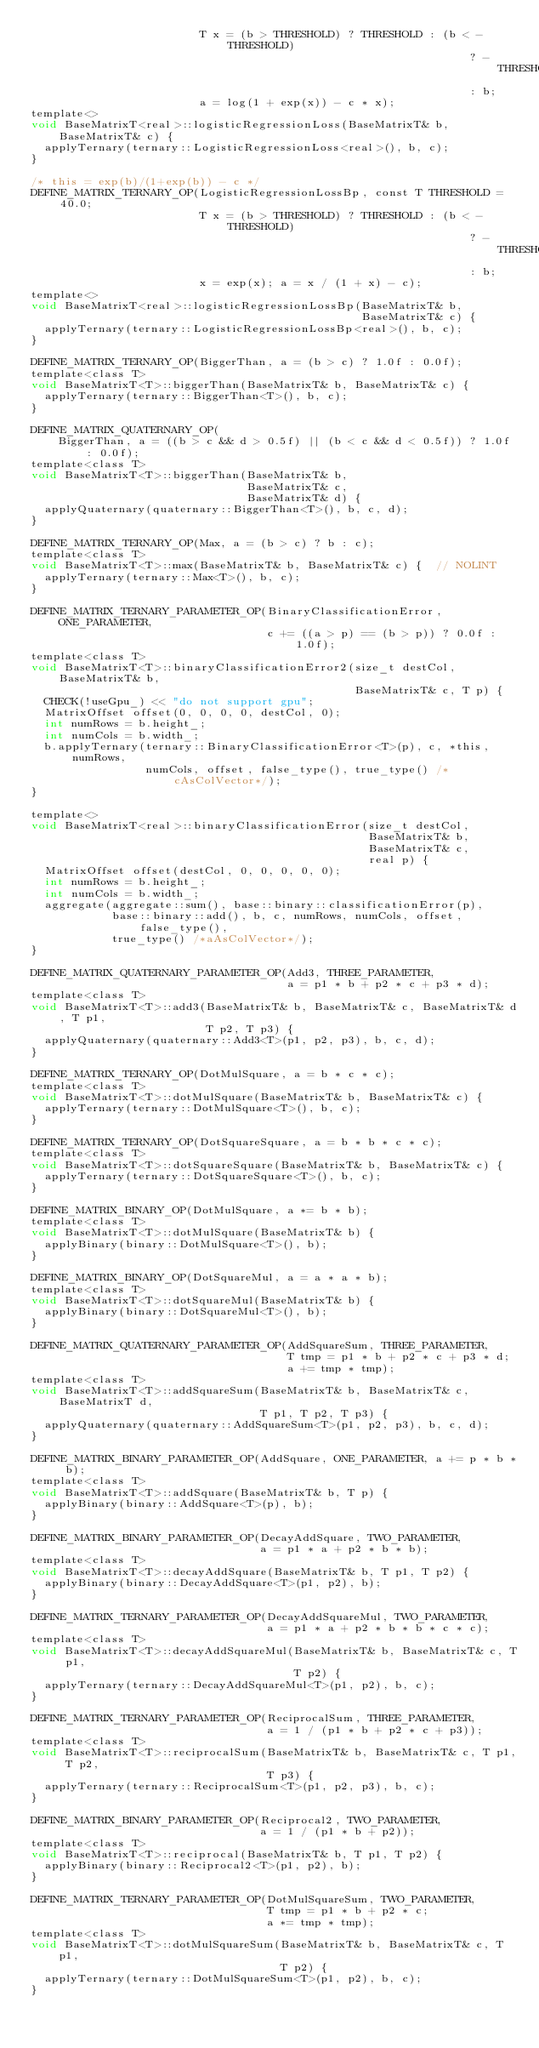<code> <loc_0><loc_0><loc_500><loc_500><_Cuda_>                         T x = (b > THRESHOLD) ? THRESHOLD : (b < -THRESHOLD)
                                                                 ? -THRESHOLD
                                                                 : b;
                         a = log(1 + exp(x)) - c * x);
template<>
void BaseMatrixT<real>::logisticRegressionLoss(BaseMatrixT& b, BaseMatrixT& c) {
  applyTernary(ternary::LogisticRegressionLoss<real>(), b, c);
}

/* this = exp(b)/(1+exp(b)) - c */
DEFINE_MATRIX_TERNARY_OP(LogisticRegressionLossBp, const T THRESHOLD = 40.0;
                         T x = (b > THRESHOLD) ? THRESHOLD : (b < -THRESHOLD)
                                                                 ? -THRESHOLD
                                                                 : b;
                         x = exp(x); a = x / (1 + x) - c);
template<>
void BaseMatrixT<real>::logisticRegressionLossBp(BaseMatrixT& b,
                                                 BaseMatrixT& c) {
  applyTernary(ternary::LogisticRegressionLossBp<real>(), b, c);
}

DEFINE_MATRIX_TERNARY_OP(BiggerThan, a = (b > c) ? 1.0f : 0.0f);
template<class T>
void BaseMatrixT<T>::biggerThan(BaseMatrixT& b, BaseMatrixT& c) {
  applyTernary(ternary::BiggerThan<T>(), b, c);
}

DEFINE_MATRIX_QUATERNARY_OP(
    BiggerThan, a = ((b > c && d > 0.5f) || (b < c && d < 0.5f)) ? 1.0f : 0.0f);
template<class T>
void BaseMatrixT<T>::biggerThan(BaseMatrixT& b,
                                BaseMatrixT& c,
                                BaseMatrixT& d) {
  applyQuaternary(quaternary::BiggerThan<T>(), b, c, d);
}

DEFINE_MATRIX_TERNARY_OP(Max, a = (b > c) ? b : c);
template<class T>
void BaseMatrixT<T>::max(BaseMatrixT& b, BaseMatrixT& c) {  // NOLINT
  applyTernary(ternary::Max<T>(), b, c);
}

DEFINE_MATRIX_TERNARY_PARAMETER_OP(BinaryClassificationError, ONE_PARAMETER,
                                   c += ((a > p) == (b > p)) ? 0.0f : 1.0f);
template<class T>
void BaseMatrixT<T>::binaryClassificationError2(size_t destCol, BaseMatrixT& b,
                                                BaseMatrixT& c, T p) {
  CHECK(!useGpu_) << "do not support gpu";
  MatrixOffset offset(0, 0, 0, 0, destCol, 0);
  int numRows = b.height_;
  int numCols = b.width_;
  b.applyTernary(ternary::BinaryClassificationError<T>(p), c, *this, numRows,
                 numCols, offset, false_type(), true_type() /*cAsColVector*/);
}

template<>
void BaseMatrixT<real>::binaryClassificationError(size_t destCol,
                                                  BaseMatrixT& b,
                                                  BaseMatrixT& c,
                                                  real p) {
  MatrixOffset offset(destCol, 0, 0, 0, 0, 0);
  int numRows = b.height_;
  int numCols = b.width_;
  aggregate(aggregate::sum(), base::binary::classificationError(p),
            base::binary::add(), b, c, numRows, numCols, offset, false_type(),
            true_type() /*aAsColVector*/);
}

DEFINE_MATRIX_QUATERNARY_PARAMETER_OP(Add3, THREE_PARAMETER,
                                      a = p1 * b + p2 * c + p3 * d);
template<class T>
void BaseMatrixT<T>::add3(BaseMatrixT& b, BaseMatrixT& c, BaseMatrixT& d, T p1,
                          T p2, T p3) {
  applyQuaternary(quaternary::Add3<T>(p1, p2, p3), b, c, d);
}

DEFINE_MATRIX_TERNARY_OP(DotMulSquare, a = b * c * c);
template<class T>
void BaseMatrixT<T>::dotMulSquare(BaseMatrixT& b, BaseMatrixT& c) {
  applyTernary(ternary::DotMulSquare<T>(), b, c);
}

DEFINE_MATRIX_TERNARY_OP(DotSquareSquare, a = b * b * c * c);
template<class T>
void BaseMatrixT<T>::dotSquareSquare(BaseMatrixT& b, BaseMatrixT& c) {
  applyTernary(ternary::DotSquareSquare<T>(), b, c);
}

DEFINE_MATRIX_BINARY_OP(DotMulSquare, a *= b * b);
template<class T>
void BaseMatrixT<T>::dotMulSquare(BaseMatrixT& b) {
  applyBinary(binary::DotMulSquare<T>(), b);
}

DEFINE_MATRIX_BINARY_OP(DotSquareMul, a = a * a * b);
template<class T>
void BaseMatrixT<T>::dotSquareMul(BaseMatrixT& b) {
  applyBinary(binary::DotSquareMul<T>(), b);
}

DEFINE_MATRIX_QUATERNARY_PARAMETER_OP(AddSquareSum, THREE_PARAMETER,
                                      T tmp = p1 * b + p2 * c + p3 * d;
                                      a += tmp * tmp);
template<class T>
void BaseMatrixT<T>::addSquareSum(BaseMatrixT& b, BaseMatrixT& c, BaseMatrixT d,
                                  T p1, T p2, T p3) {
  applyQuaternary(quaternary::AddSquareSum<T>(p1, p2, p3), b, c, d);
}

DEFINE_MATRIX_BINARY_PARAMETER_OP(AddSquare, ONE_PARAMETER, a += p * b * b);
template<class T>
void BaseMatrixT<T>::addSquare(BaseMatrixT& b, T p) {
  applyBinary(binary::AddSquare<T>(p), b);
}

DEFINE_MATRIX_BINARY_PARAMETER_OP(DecayAddSquare, TWO_PARAMETER,
                                  a = p1 * a + p2 * b * b);
template<class T>
void BaseMatrixT<T>::decayAddSquare(BaseMatrixT& b, T p1, T p2) {
  applyBinary(binary::DecayAddSquare<T>(p1, p2), b);
}

DEFINE_MATRIX_TERNARY_PARAMETER_OP(DecayAddSquareMul, TWO_PARAMETER,
                                   a = p1 * a + p2 * b * b * c * c);
template<class T>
void BaseMatrixT<T>::decayAddSquareMul(BaseMatrixT& b, BaseMatrixT& c, T p1,
                                       T p2) {
  applyTernary(ternary::DecayAddSquareMul<T>(p1, p2), b, c);
}

DEFINE_MATRIX_TERNARY_PARAMETER_OP(ReciprocalSum, THREE_PARAMETER,
                                   a = 1 / (p1 * b + p2 * c + p3));
template<class T>
void BaseMatrixT<T>::reciprocalSum(BaseMatrixT& b, BaseMatrixT& c, T p1, T p2,
                                   T p3) {
  applyTernary(ternary::ReciprocalSum<T>(p1, p2, p3), b, c);
}

DEFINE_MATRIX_BINARY_PARAMETER_OP(Reciprocal2, TWO_PARAMETER,
                                  a = 1 / (p1 * b + p2));
template<class T>
void BaseMatrixT<T>::reciprocal(BaseMatrixT& b, T p1, T p2) {
  applyBinary(binary::Reciprocal2<T>(p1, p2), b);
}

DEFINE_MATRIX_TERNARY_PARAMETER_OP(DotMulSquareSum, TWO_PARAMETER,
                                   T tmp = p1 * b + p2 * c;
                                   a *= tmp * tmp);
template<class T>
void BaseMatrixT<T>::dotMulSquareSum(BaseMatrixT& b, BaseMatrixT& c, T p1,
                                     T p2) {
  applyTernary(ternary::DotMulSquareSum<T>(p1, p2), b, c);
}
</code> 